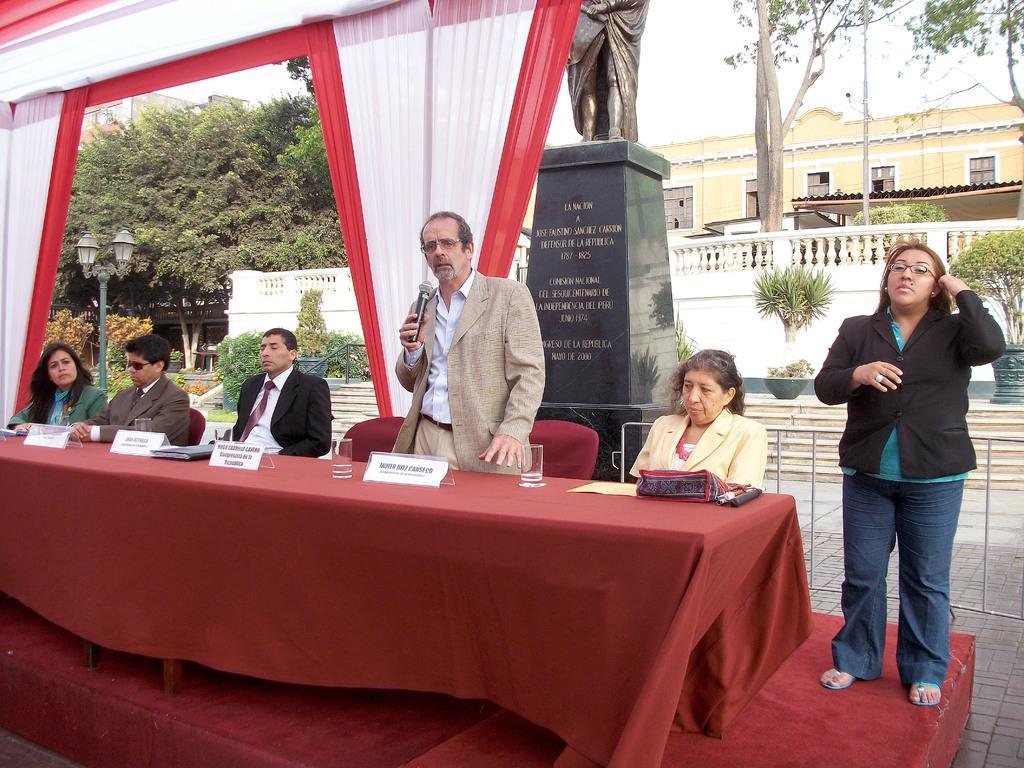In one or two sentences, can you explain what this image depicts? In this image, I can see a group of 6 people over here and 3 of them are men and 3 of them are women. In the background I can see the trees, street light, a house and a statue. 